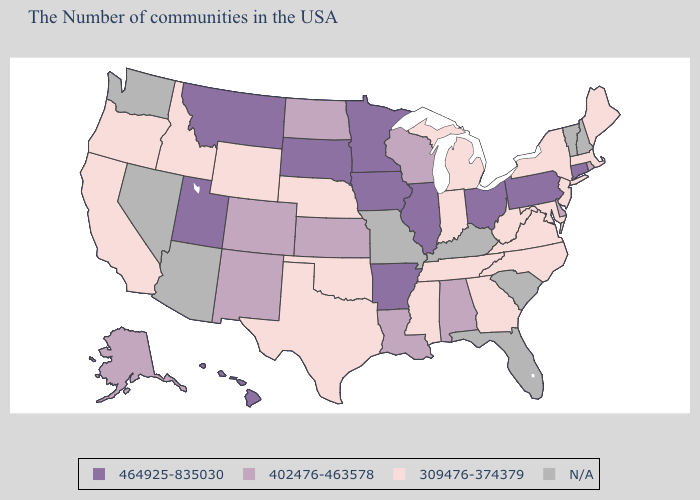Does Alaska have the highest value in the USA?
Keep it brief. No. What is the value of Hawaii?
Concise answer only. 464925-835030. What is the lowest value in the West?
Write a very short answer. 309476-374379. How many symbols are there in the legend?
Answer briefly. 4. Does Virginia have the highest value in the USA?
Quick response, please. No. What is the lowest value in states that border Utah?
Give a very brief answer. 309476-374379. Among the states that border South Dakota , which have the lowest value?
Short answer required. Nebraska, Wyoming. How many symbols are there in the legend?
Answer briefly. 4. What is the value of California?
Answer briefly. 309476-374379. Among the states that border Idaho , does Montana have the highest value?
Short answer required. Yes. Which states hav the highest value in the West?
Keep it brief. Utah, Montana, Hawaii. Name the states that have a value in the range 309476-374379?
Concise answer only. Maine, Massachusetts, New York, New Jersey, Maryland, Virginia, North Carolina, West Virginia, Georgia, Michigan, Indiana, Tennessee, Mississippi, Nebraska, Oklahoma, Texas, Wyoming, Idaho, California, Oregon. Does Nebraska have the highest value in the MidWest?
Be succinct. No. Which states have the lowest value in the USA?
Keep it brief. Maine, Massachusetts, New York, New Jersey, Maryland, Virginia, North Carolina, West Virginia, Georgia, Michigan, Indiana, Tennessee, Mississippi, Nebraska, Oklahoma, Texas, Wyoming, Idaho, California, Oregon. What is the highest value in states that border North Dakota?
Short answer required. 464925-835030. 